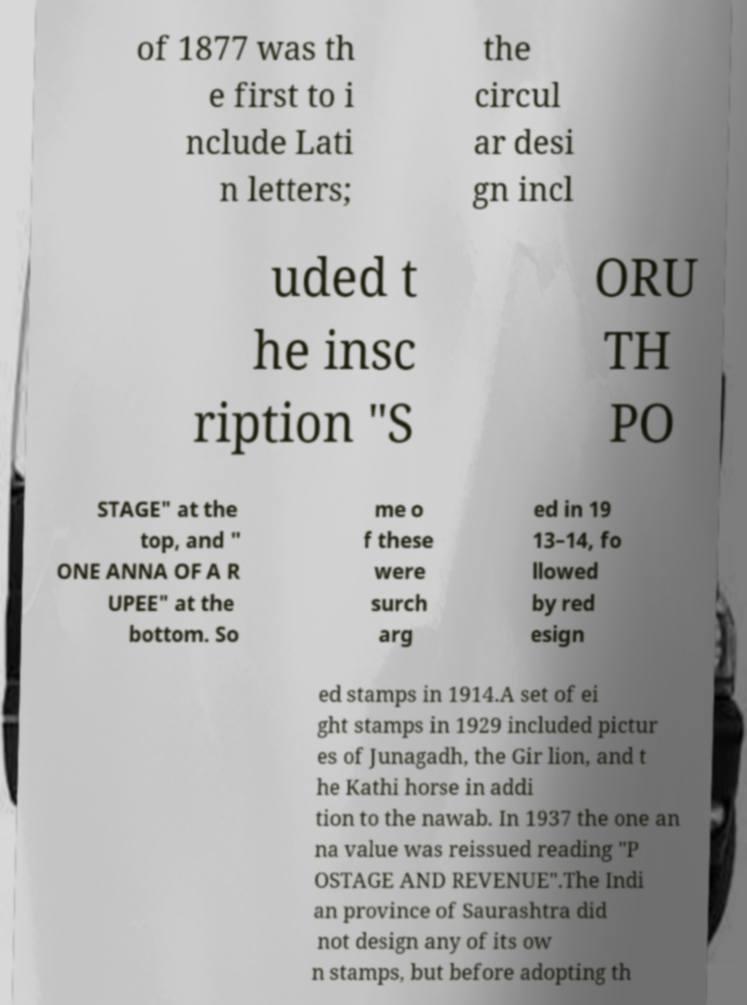Please identify and transcribe the text found in this image. of 1877 was th e first to i nclude Lati n letters; the circul ar desi gn incl uded t he insc ription "S ORU TH PO STAGE" at the top, and " ONE ANNA OF A R UPEE" at the bottom. So me o f these were surch arg ed in 19 13–14, fo llowed by red esign ed stamps in 1914.A set of ei ght stamps in 1929 included pictur es of Junagadh, the Gir lion, and t he Kathi horse in addi tion to the nawab. In 1937 the one an na value was reissued reading "P OSTAGE AND REVENUE".The Indi an province of Saurashtra did not design any of its ow n stamps, but before adopting th 